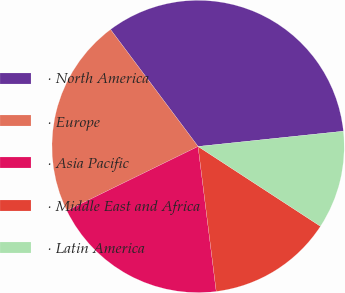<chart> <loc_0><loc_0><loc_500><loc_500><pie_chart><fcel>· North America<fcel>· Europe<fcel>· Asia Pacific<fcel>· Middle East and Africa<fcel>· Latin America<nl><fcel>33.56%<fcel>22.01%<fcel>19.74%<fcel>13.82%<fcel>10.86%<nl></chart> 